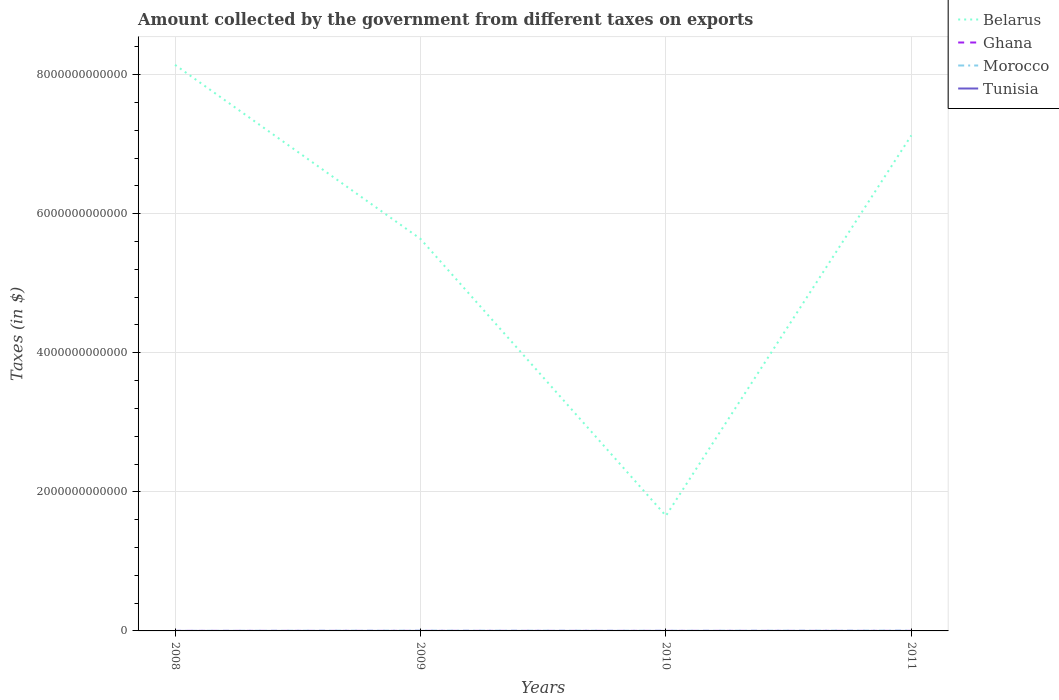How many different coloured lines are there?
Your answer should be compact. 4. Is the number of lines equal to the number of legend labels?
Ensure brevity in your answer.  Yes. Across all years, what is the maximum amount collected by the government from taxes on exports in Tunisia?
Your response must be concise. 1.57e+07. What is the total amount collected by the government from taxes on exports in Tunisia in the graph?
Your answer should be very brief. -2.30e+06. What is the difference between the highest and the second highest amount collected by the government from taxes on exports in Morocco?
Provide a short and direct response. 2.94e+09. What is the difference between the highest and the lowest amount collected by the government from taxes on exports in Belarus?
Your answer should be very brief. 2. How many lines are there?
Provide a short and direct response. 4. How many years are there in the graph?
Provide a short and direct response. 4. What is the difference between two consecutive major ticks on the Y-axis?
Your answer should be compact. 2.00e+12. Does the graph contain any zero values?
Offer a terse response. No. How are the legend labels stacked?
Offer a very short reply. Vertical. What is the title of the graph?
Your answer should be compact. Amount collected by the government from different taxes on exports. Does "St. Lucia" appear as one of the legend labels in the graph?
Make the answer very short. No. What is the label or title of the X-axis?
Give a very brief answer. Years. What is the label or title of the Y-axis?
Make the answer very short. Taxes (in $). What is the Taxes (in $) in Belarus in 2008?
Your answer should be very brief. 8.14e+12. What is the Taxes (in $) in Ghana in 2008?
Provide a short and direct response. 4.00e+07. What is the Taxes (in $) of Morocco in 2008?
Give a very brief answer. 6.21e+07. What is the Taxes (in $) in Tunisia in 2008?
Keep it short and to the point. 2.51e+07. What is the Taxes (in $) of Belarus in 2009?
Provide a short and direct response. 5.64e+12. What is the Taxes (in $) in Ghana in 2009?
Make the answer very short. 1.68e+07. What is the Taxes (in $) of Morocco in 2009?
Offer a terse response. 2.46e+09. What is the Taxes (in $) of Tunisia in 2009?
Provide a short and direct response. 1.57e+07. What is the Taxes (in $) of Belarus in 2010?
Your answer should be compact. 1.66e+12. What is the Taxes (in $) in Ghana in 2010?
Your answer should be very brief. 9.47e+07. What is the Taxes (in $) of Tunisia in 2010?
Offer a very short reply. 1.75e+07. What is the Taxes (in $) of Belarus in 2011?
Ensure brevity in your answer.  7.13e+12. What is the Taxes (in $) of Morocco in 2011?
Make the answer very short. 3.00e+09. What is the Taxes (in $) of Tunisia in 2011?
Offer a very short reply. 1.80e+07. Across all years, what is the maximum Taxes (in $) of Belarus?
Your answer should be compact. 8.14e+12. Across all years, what is the maximum Taxes (in $) of Ghana?
Make the answer very short. 9.47e+07. Across all years, what is the maximum Taxes (in $) in Morocco?
Your answer should be compact. 3.00e+09. Across all years, what is the maximum Taxes (in $) of Tunisia?
Your answer should be compact. 2.51e+07. Across all years, what is the minimum Taxes (in $) in Belarus?
Provide a succinct answer. 1.66e+12. Across all years, what is the minimum Taxes (in $) in Ghana?
Provide a succinct answer. 5.00e+06. Across all years, what is the minimum Taxes (in $) of Morocco?
Make the answer very short. 6.21e+07. Across all years, what is the minimum Taxes (in $) in Tunisia?
Provide a succinct answer. 1.57e+07. What is the total Taxes (in $) in Belarus in the graph?
Provide a succinct answer. 2.26e+13. What is the total Taxes (in $) of Ghana in the graph?
Provide a short and direct response. 1.56e+08. What is the total Taxes (in $) of Morocco in the graph?
Make the answer very short. 6.52e+09. What is the total Taxes (in $) in Tunisia in the graph?
Keep it short and to the point. 7.63e+07. What is the difference between the Taxes (in $) of Belarus in 2008 and that in 2009?
Keep it short and to the point. 2.50e+12. What is the difference between the Taxes (in $) of Ghana in 2008 and that in 2009?
Your answer should be compact. 2.32e+07. What is the difference between the Taxes (in $) of Morocco in 2008 and that in 2009?
Keep it short and to the point. -2.39e+09. What is the difference between the Taxes (in $) in Tunisia in 2008 and that in 2009?
Your answer should be compact. 9.40e+06. What is the difference between the Taxes (in $) in Belarus in 2008 and that in 2010?
Ensure brevity in your answer.  6.48e+12. What is the difference between the Taxes (in $) of Ghana in 2008 and that in 2010?
Keep it short and to the point. -5.47e+07. What is the difference between the Taxes (in $) of Morocco in 2008 and that in 2010?
Your answer should be very brief. -9.38e+08. What is the difference between the Taxes (in $) in Tunisia in 2008 and that in 2010?
Offer a terse response. 7.60e+06. What is the difference between the Taxes (in $) of Belarus in 2008 and that in 2011?
Your response must be concise. 1.01e+12. What is the difference between the Taxes (in $) in Ghana in 2008 and that in 2011?
Provide a succinct answer. 3.50e+07. What is the difference between the Taxes (in $) in Morocco in 2008 and that in 2011?
Provide a short and direct response. -2.94e+09. What is the difference between the Taxes (in $) in Tunisia in 2008 and that in 2011?
Provide a short and direct response. 7.10e+06. What is the difference between the Taxes (in $) in Belarus in 2009 and that in 2010?
Provide a succinct answer. 3.98e+12. What is the difference between the Taxes (in $) in Ghana in 2009 and that in 2010?
Keep it short and to the point. -7.79e+07. What is the difference between the Taxes (in $) of Morocco in 2009 and that in 2010?
Make the answer very short. 1.46e+09. What is the difference between the Taxes (in $) of Tunisia in 2009 and that in 2010?
Your answer should be very brief. -1.80e+06. What is the difference between the Taxes (in $) in Belarus in 2009 and that in 2011?
Keep it short and to the point. -1.49e+12. What is the difference between the Taxes (in $) in Ghana in 2009 and that in 2011?
Give a very brief answer. 1.18e+07. What is the difference between the Taxes (in $) in Morocco in 2009 and that in 2011?
Keep it short and to the point. -5.44e+08. What is the difference between the Taxes (in $) of Tunisia in 2009 and that in 2011?
Your answer should be compact. -2.30e+06. What is the difference between the Taxes (in $) of Belarus in 2010 and that in 2011?
Provide a succinct answer. -5.47e+12. What is the difference between the Taxes (in $) of Ghana in 2010 and that in 2011?
Your answer should be compact. 8.97e+07. What is the difference between the Taxes (in $) in Morocco in 2010 and that in 2011?
Make the answer very short. -2.00e+09. What is the difference between the Taxes (in $) in Tunisia in 2010 and that in 2011?
Offer a terse response. -5.00e+05. What is the difference between the Taxes (in $) in Belarus in 2008 and the Taxes (in $) in Ghana in 2009?
Provide a short and direct response. 8.14e+12. What is the difference between the Taxes (in $) of Belarus in 2008 and the Taxes (in $) of Morocco in 2009?
Your answer should be very brief. 8.14e+12. What is the difference between the Taxes (in $) of Belarus in 2008 and the Taxes (in $) of Tunisia in 2009?
Ensure brevity in your answer.  8.14e+12. What is the difference between the Taxes (in $) of Ghana in 2008 and the Taxes (in $) of Morocco in 2009?
Provide a short and direct response. -2.42e+09. What is the difference between the Taxes (in $) of Ghana in 2008 and the Taxes (in $) of Tunisia in 2009?
Provide a short and direct response. 2.43e+07. What is the difference between the Taxes (in $) of Morocco in 2008 and the Taxes (in $) of Tunisia in 2009?
Ensure brevity in your answer.  4.64e+07. What is the difference between the Taxes (in $) in Belarus in 2008 and the Taxes (in $) in Ghana in 2010?
Your answer should be very brief. 8.14e+12. What is the difference between the Taxes (in $) in Belarus in 2008 and the Taxes (in $) in Morocco in 2010?
Ensure brevity in your answer.  8.14e+12. What is the difference between the Taxes (in $) of Belarus in 2008 and the Taxes (in $) of Tunisia in 2010?
Offer a very short reply. 8.14e+12. What is the difference between the Taxes (in $) in Ghana in 2008 and the Taxes (in $) in Morocco in 2010?
Make the answer very short. -9.60e+08. What is the difference between the Taxes (in $) of Ghana in 2008 and the Taxes (in $) of Tunisia in 2010?
Offer a terse response. 2.25e+07. What is the difference between the Taxes (in $) of Morocco in 2008 and the Taxes (in $) of Tunisia in 2010?
Give a very brief answer. 4.46e+07. What is the difference between the Taxes (in $) in Belarus in 2008 and the Taxes (in $) in Ghana in 2011?
Ensure brevity in your answer.  8.14e+12. What is the difference between the Taxes (in $) in Belarus in 2008 and the Taxes (in $) in Morocco in 2011?
Offer a terse response. 8.14e+12. What is the difference between the Taxes (in $) in Belarus in 2008 and the Taxes (in $) in Tunisia in 2011?
Ensure brevity in your answer.  8.14e+12. What is the difference between the Taxes (in $) of Ghana in 2008 and the Taxes (in $) of Morocco in 2011?
Offer a terse response. -2.96e+09. What is the difference between the Taxes (in $) of Ghana in 2008 and the Taxes (in $) of Tunisia in 2011?
Your response must be concise. 2.20e+07. What is the difference between the Taxes (in $) of Morocco in 2008 and the Taxes (in $) of Tunisia in 2011?
Your response must be concise. 4.41e+07. What is the difference between the Taxes (in $) in Belarus in 2009 and the Taxes (in $) in Ghana in 2010?
Ensure brevity in your answer.  5.64e+12. What is the difference between the Taxes (in $) of Belarus in 2009 and the Taxes (in $) of Morocco in 2010?
Offer a very short reply. 5.64e+12. What is the difference between the Taxes (in $) in Belarus in 2009 and the Taxes (in $) in Tunisia in 2010?
Provide a succinct answer. 5.64e+12. What is the difference between the Taxes (in $) in Ghana in 2009 and the Taxes (in $) in Morocco in 2010?
Provide a short and direct response. -9.83e+08. What is the difference between the Taxes (in $) in Ghana in 2009 and the Taxes (in $) in Tunisia in 2010?
Make the answer very short. -7.41e+05. What is the difference between the Taxes (in $) of Morocco in 2009 and the Taxes (in $) of Tunisia in 2010?
Your answer should be very brief. 2.44e+09. What is the difference between the Taxes (in $) of Belarus in 2009 and the Taxes (in $) of Ghana in 2011?
Offer a terse response. 5.64e+12. What is the difference between the Taxes (in $) of Belarus in 2009 and the Taxes (in $) of Morocco in 2011?
Provide a short and direct response. 5.63e+12. What is the difference between the Taxes (in $) of Belarus in 2009 and the Taxes (in $) of Tunisia in 2011?
Keep it short and to the point. 5.64e+12. What is the difference between the Taxes (in $) of Ghana in 2009 and the Taxes (in $) of Morocco in 2011?
Ensure brevity in your answer.  -2.98e+09. What is the difference between the Taxes (in $) in Ghana in 2009 and the Taxes (in $) in Tunisia in 2011?
Provide a succinct answer. -1.24e+06. What is the difference between the Taxes (in $) of Morocco in 2009 and the Taxes (in $) of Tunisia in 2011?
Your answer should be compact. 2.44e+09. What is the difference between the Taxes (in $) of Belarus in 2010 and the Taxes (in $) of Ghana in 2011?
Provide a short and direct response. 1.66e+12. What is the difference between the Taxes (in $) of Belarus in 2010 and the Taxes (in $) of Morocco in 2011?
Provide a short and direct response. 1.65e+12. What is the difference between the Taxes (in $) of Belarus in 2010 and the Taxes (in $) of Tunisia in 2011?
Make the answer very short. 1.66e+12. What is the difference between the Taxes (in $) of Ghana in 2010 and the Taxes (in $) of Morocco in 2011?
Offer a very short reply. -2.91e+09. What is the difference between the Taxes (in $) in Ghana in 2010 and the Taxes (in $) in Tunisia in 2011?
Your answer should be very brief. 7.67e+07. What is the difference between the Taxes (in $) of Morocco in 2010 and the Taxes (in $) of Tunisia in 2011?
Give a very brief answer. 9.82e+08. What is the average Taxes (in $) in Belarus per year?
Keep it short and to the point. 5.64e+12. What is the average Taxes (in $) of Ghana per year?
Your answer should be very brief. 3.91e+07. What is the average Taxes (in $) in Morocco per year?
Ensure brevity in your answer.  1.63e+09. What is the average Taxes (in $) of Tunisia per year?
Offer a very short reply. 1.91e+07. In the year 2008, what is the difference between the Taxes (in $) of Belarus and Taxes (in $) of Ghana?
Ensure brevity in your answer.  8.14e+12. In the year 2008, what is the difference between the Taxes (in $) of Belarus and Taxes (in $) of Morocco?
Your answer should be compact. 8.14e+12. In the year 2008, what is the difference between the Taxes (in $) in Belarus and Taxes (in $) in Tunisia?
Your answer should be compact. 8.14e+12. In the year 2008, what is the difference between the Taxes (in $) in Ghana and Taxes (in $) in Morocco?
Make the answer very short. -2.21e+07. In the year 2008, what is the difference between the Taxes (in $) in Ghana and Taxes (in $) in Tunisia?
Provide a succinct answer. 1.49e+07. In the year 2008, what is the difference between the Taxes (in $) of Morocco and Taxes (in $) of Tunisia?
Ensure brevity in your answer.  3.70e+07. In the year 2009, what is the difference between the Taxes (in $) of Belarus and Taxes (in $) of Ghana?
Ensure brevity in your answer.  5.64e+12. In the year 2009, what is the difference between the Taxes (in $) of Belarus and Taxes (in $) of Morocco?
Offer a terse response. 5.63e+12. In the year 2009, what is the difference between the Taxes (in $) in Belarus and Taxes (in $) in Tunisia?
Offer a terse response. 5.64e+12. In the year 2009, what is the difference between the Taxes (in $) in Ghana and Taxes (in $) in Morocco?
Offer a terse response. -2.44e+09. In the year 2009, what is the difference between the Taxes (in $) of Ghana and Taxes (in $) of Tunisia?
Keep it short and to the point. 1.06e+06. In the year 2009, what is the difference between the Taxes (in $) in Morocco and Taxes (in $) in Tunisia?
Keep it short and to the point. 2.44e+09. In the year 2010, what is the difference between the Taxes (in $) of Belarus and Taxes (in $) of Ghana?
Give a very brief answer. 1.66e+12. In the year 2010, what is the difference between the Taxes (in $) of Belarus and Taxes (in $) of Morocco?
Provide a succinct answer. 1.65e+12. In the year 2010, what is the difference between the Taxes (in $) in Belarus and Taxes (in $) in Tunisia?
Give a very brief answer. 1.66e+12. In the year 2010, what is the difference between the Taxes (in $) in Ghana and Taxes (in $) in Morocco?
Your answer should be compact. -9.05e+08. In the year 2010, what is the difference between the Taxes (in $) in Ghana and Taxes (in $) in Tunisia?
Ensure brevity in your answer.  7.72e+07. In the year 2010, what is the difference between the Taxes (in $) in Morocco and Taxes (in $) in Tunisia?
Ensure brevity in your answer.  9.82e+08. In the year 2011, what is the difference between the Taxes (in $) in Belarus and Taxes (in $) in Ghana?
Your answer should be compact. 7.13e+12. In the year 2011, what is the difference between the Taxes (in $) of Belarus and Taxes (in $) of Morocco?
Provide a short and direct response. 7.12e+12. In the year 2011, what is the difference between the Taxes (in $) of Belarus and Taxes (in $) of Tunisia?
Ensure brevity in your answer.  7.13e+12. In the year 2011, what is the difference between the Taxes (in $) in Ghana and Taxes (in $) in Morocco?
Your response must be concise. -3.00e+09. In the year 2011, what is the difference between the Taxes (in $) of Ghana and Taxes (in $) of Tunisia?
Your response must be concise. -1.30e+07. In the year 2011, what is the difference between the Taxes (in $) of Morocco and Taxes (in $) of Tunisia?
Your answer should be very brief. 2.98e+09. What is the ratio of the Taxes (in $) of Belarus in 2008 to that in 2009?
Ensure brevity in your answer.  1.44. What is the ratio of the Taxes (in $) of Ghana in 2008 to that in 2009?
Make the answer very short. 2.39. What is the ratio of the Taxes (in $) of Morocco in 2008 to that in 2009?
Make the answer very short. 0.03. What is the ratio of the Taxes (in $) of Tunisia in 2008 to that in 2009?
Make the answer very short. 1.6. What is the ratio of the Taxes (in $) in Belarus in 2008 to that in 2010?
Make the answer very short. 4.92. What is the ratio of the Taxes (in $) in Ghana in 2008 to that in 2010?
Give a very brief answer. 0.42. What is the ratio of the Taxes (in $) in Morocco in 2008 to that in 2010?
Make the answer very short. 0.06. What is the ratio of the Taxes (in $) in Tunisia in 2008 to that in 2010?
Ensure brevity in your answer.  1.43. What is the ratio of the Taxes (in $) of Belarus in 2008 to that in 2011?
Provide a succinct answer. 1.14. What is the ratio of the Taxes (in $) of Ghana in 2008 to that in 2011?
Your answer should be compact. 8. What is the ratio of the Taxes (in $) in Morocco in 2008 to that in 2011?
Keep it short and to the point. 0.02. What is the ratio of the Taxes (in $) in Tunisia in 2008 to that in 2011?
Give a very brief answer. 1.39. What is the ratio of the Taxes (in $) of Belarus in 2009 to that in 2010?
Your answer should be very brief. 3.4. What is the ratio of the Taxes (in $) of Ghana in 2009 to that in 2010?
Ensure brevity in your answer.  0.18. What is the ratio of the Taxes (in $) in Morocco in 2009 to that in 2010?
Offer a very short reply. 2.46. What is the ratio of the Taxes (in $) in Tunisia in 2009 to that in 2010?
Your response must be concise. 0.9. What is the ratio of the Taxes (in $) in Belarus in 2009 to that in 2011?
Provide a short and direct response. 0.79. What is the ratio of the Taxes (in $) of Ghana in 2009 to that in 2011?
Your answer should be compact. 3.35. What is the ratio of the Taxes (in $) in Morocco in 2009 to that in 2011?
Keep it short and to the point. 0.82. What is the ratio of the Taxes (in $) of Tunisia in 2009 to that in 2011?
Keep it short and to the point. 0.87. What is the ratio of the Taxes (in $) of Belarus in 2010 to that in 2011?
Provide a succinct answer. 0.23. What is the ratio of the Taxes (in $) of Ghana in 2010 to that in 2011?
Keep it short and to the point. 18.93. What is the ratio of the Taxes (in $) in Tunisia in 2010 to that in 2011?
Give a very brief answer. 0.97. What is the difference between the highest and the second highest Taxes (in $) in Belarus?
Your answer should be compact. 1.01e+12. What is the difference between the highest and the second highest Taxes (in $) of Ghana?
Make the answer very short. 5.47e+07. What is the difference between the highest and the second highest Taxes (in $) of Morocco?
Your response must be concise. 5.44e+08. What is the difference between the highest and the second highest Taxes (in $) of Tunisia?
Provide a short and direct response. 7.10e+06. What is the difference between the highest and the lowest Taxes (in $) in Belarus?
Provide a succinct answer. 6.48e+12. What is the difference between the highest and the lowest Taxes (in $) of Ghana?
Give a very brief answer. 8.97e+07. What is the difference between the highest and the lowest Taxes (in $) of Morocco?
Offer a very short reply. 2.94e+09. What is the difference between the highest and the lowest Taxes (in $) in Tunisia?
Keep it short and to the point. 9.40e+06. 